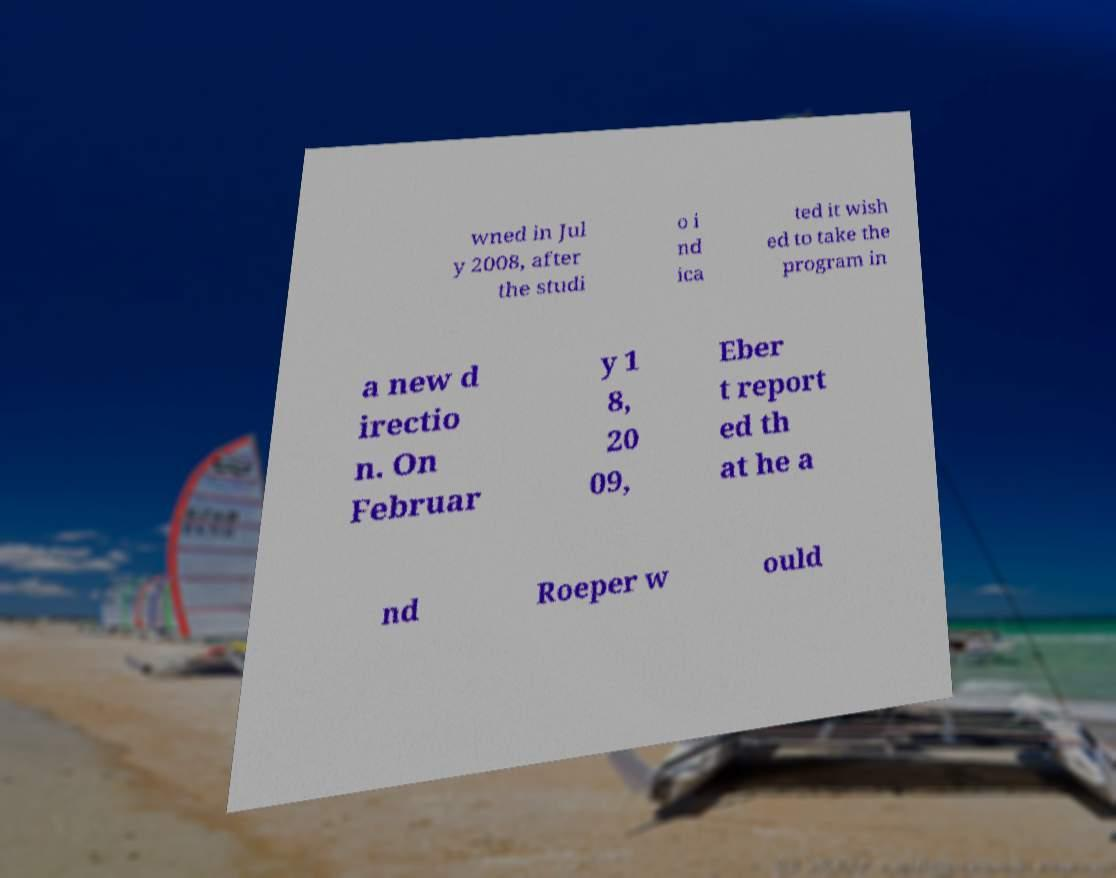Can you accurately transcribe the text from the provided image for me? wned in Jul y 2008, after the studi o i nd ica ted it wish ed to take the program in a new d irectio n. On Februar y 1 8, 20 09, Eber t report ed th at he a nd Roeper w ould 